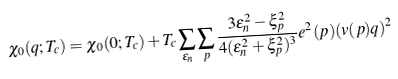Convert formula to latex. <formula><loc_0><loc_0><loc_500><loc_500>\chi _ { 0 } ( { q } ; T _ { c } ) = \chi _ { 0 } ( 0 ; T _ { c } ) + T _ { c } \sum _ { \varepsilon _ { n } } \sum _ { p } \frac { 3 \varepsilon _ { n } ^ { 2 } - \xi _ { p } ^ { 2 } } { 4 ( \varepsilon _ { n } ^ { 2 } + \xi _ { p } ^ { 2 } ) ^ { 3 } } e ^ { 2 } ( { p } ) ( { v } ( { p } ) { q } ) ^ { 2 }</formula> 